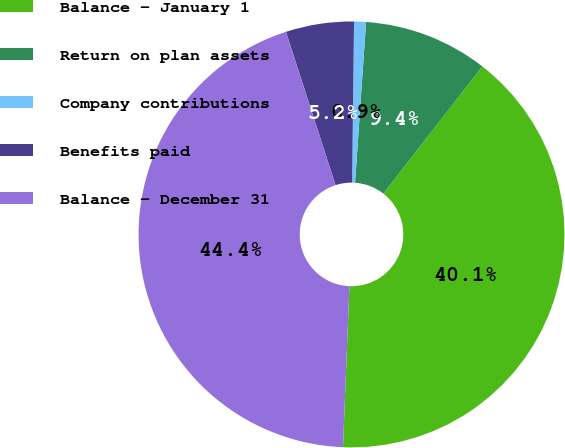Convert chart to OTSL. <chart><loc_0><loc_0><loc_500><loc_500><pie_chart><fcel>Balance - January 1<fcel>Return on plan assets<fcel>Company contributions<fcel>Benefits paid<fcel>Balance - December 31<nl><fcel>40.11%<fcel>9.44%<fcel>0.9%<fcel>5.17%<fcel>44.38%<nl></chart> 